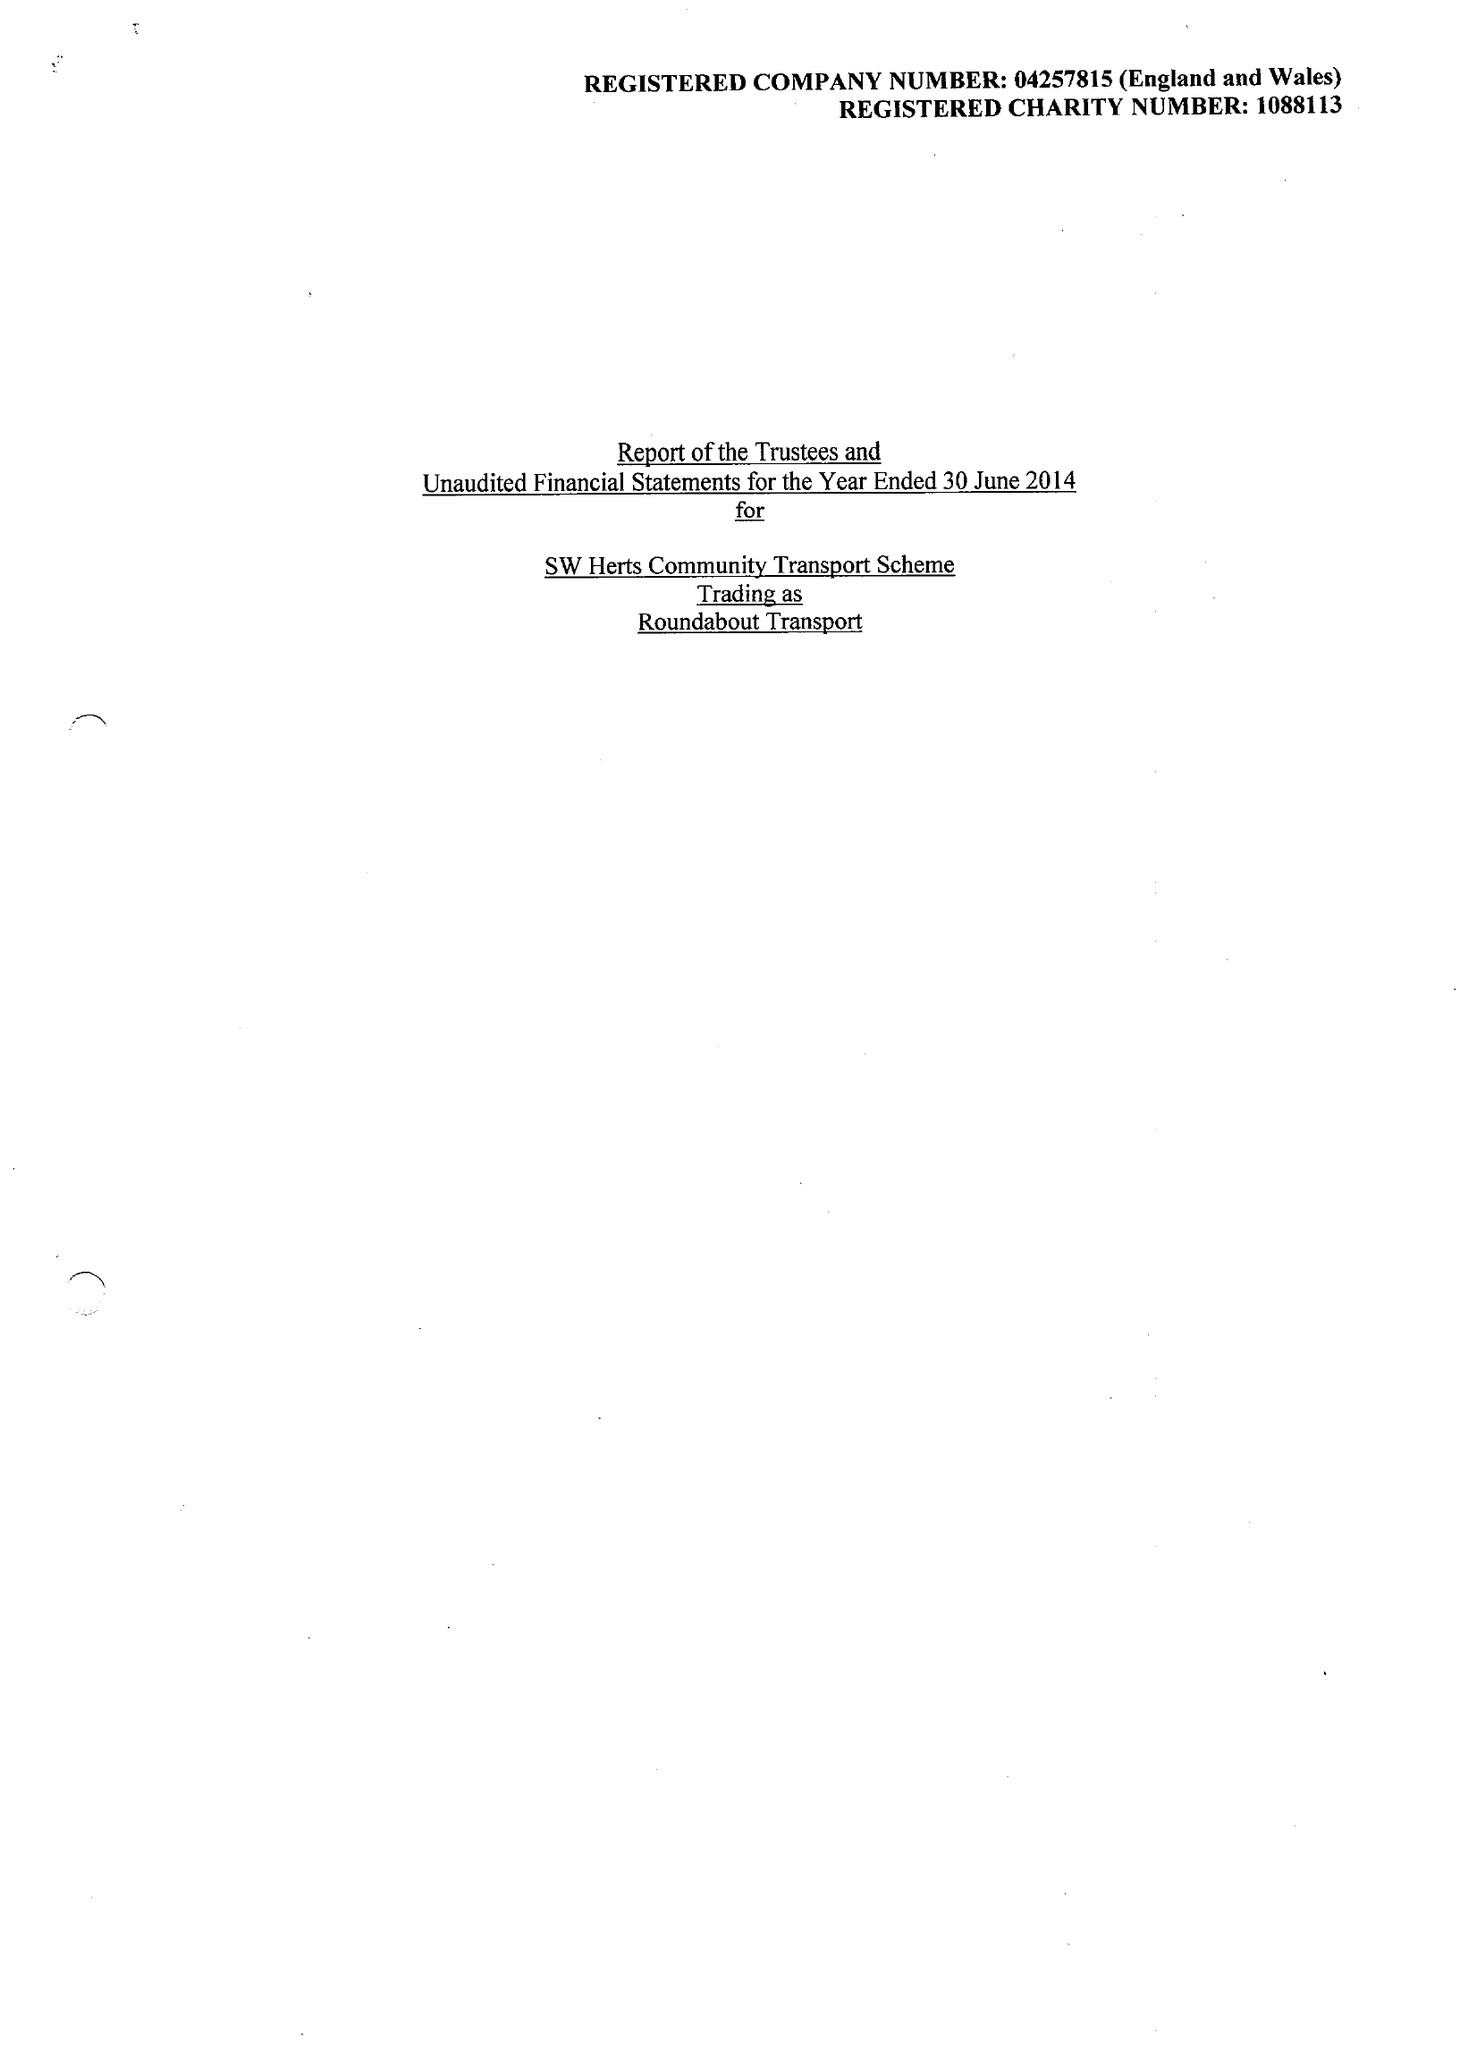What is the value for the address__post_town?
Answer the question using a single word or phrase. RICKMANSWORTH 